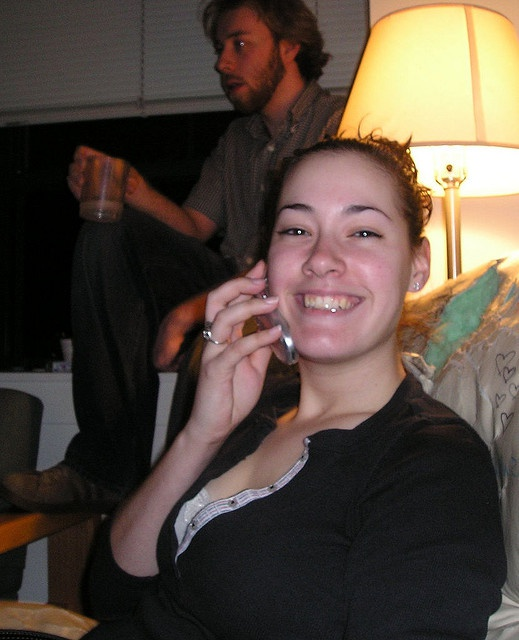Describe the objects in this image and their specific colors. I can see people in black, gray, and darkgray tones, people in black, maroon, brown, and gray tones, chair in black, gray, and teal tones, chair in black, gray, and darkgray tones, and chair in black, gray, and maroon tones in this image. 